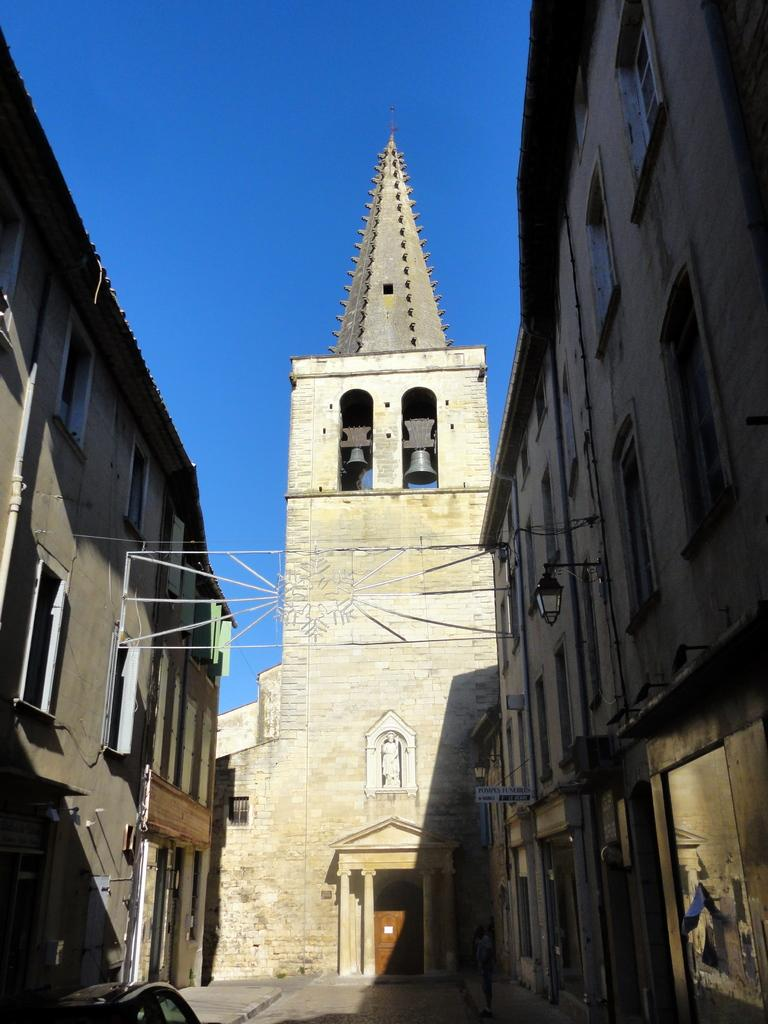What type of structures can be seen in the image? There are buildings in the image. What objects are hanging in the image? There are bells in the image. What artistic creation is present in the image? There is a sculpture in the image. What flat surface is visible in the image? There is a board in the image. What mode of transportation can be seen on the road in the image? There is a car on the road in the image. What is visible at the top of the image? The sky is visible at the top of the image. What type of glass can be seen in the alley in the image? There is no alley or glass present in the image. What material is the tin used for in the image? There is no tin present in the image. 